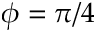Convert formula to latex. <formula><loc_0><loc_0><loc_500><loc_500>\phi = \pi / 4</formula> 